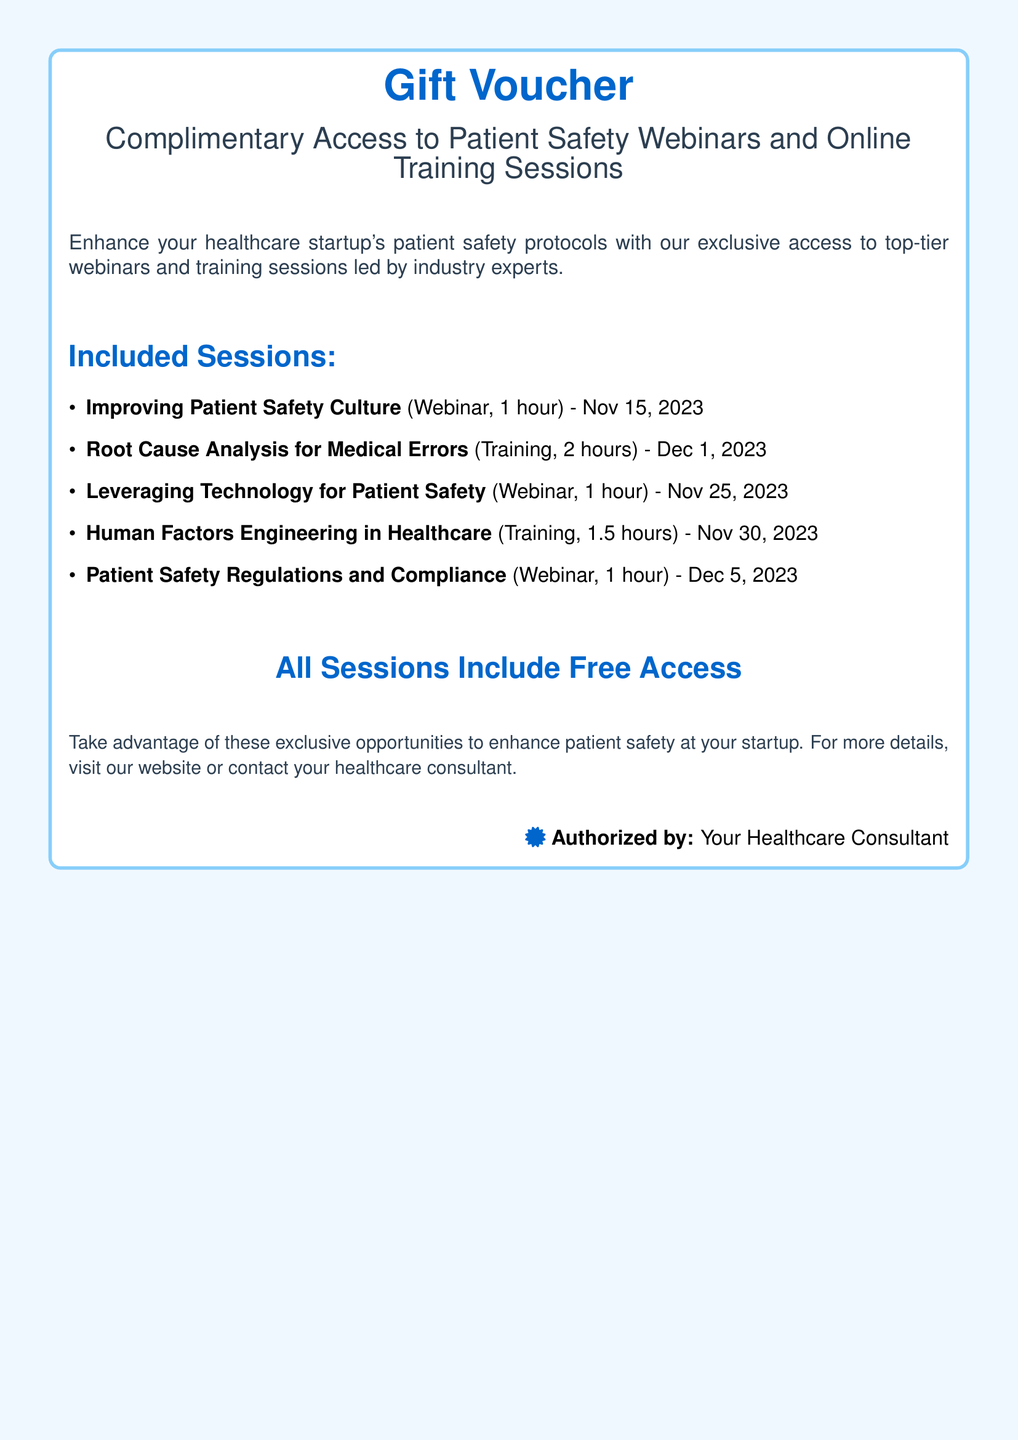What is the title of the gift voucher? The title of the gift voucher is highlighted at the top of the document.
Answer: Gift Voucher How many training sessions are included? The document lists the sessions which include both webinars and training sessions.
Answer: 2 What is the date for the "Root Cause Analysis for Medical Errors" training? The date is mentioned alongside the training session title.
Answer: Dec 1, 2023 What is the duration of the "Human Factors Engineering in Healthcare" training? The duration is specified next to the training session title.
Answer: 1.5 hours Who is the gift voucher authorized by? The author's name is mentioned at the bottom of the document.
Answer: Your Healthcare Consultant How many total webinars are listed in the document? The document enumerates the types of sessions, separating them into webinars and trainings.
Answer: 3 What is the primary focus of the webinars and training sessions? The overarching theme is presented in the introductory description of the voucher.
Answer: Patient safety What session occurs immediately before the "Patient Safety Regulations and Compliance" webinar? By analyzing the list of sessions, the order of occurrence can be deduced.
Answer: Leveraging Technology for Patient Safety What color is the title of the gift voucher written in? The color is specified in the document's formatting for the title text.
Answer: Blue 